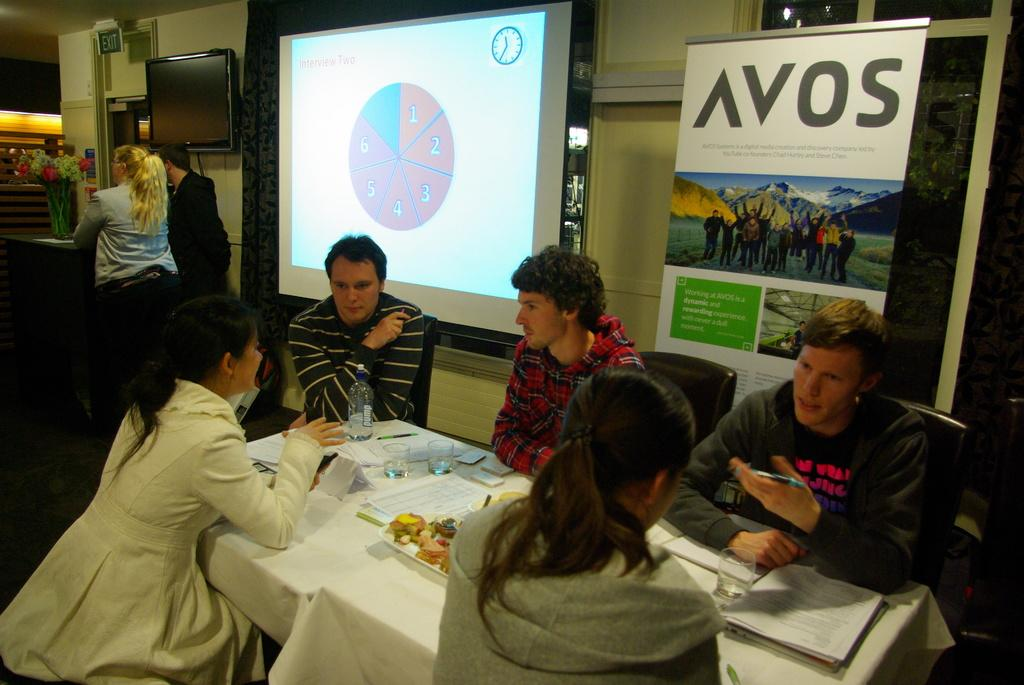What are the people in the image doing? People are sitting on chairs near a table in the image. What objects can be seen on the table? There is a bottle, a paper, a glass, a flower, and a book on the table. Is there any electronic device present in the image? Yes, there is a screen present in the image. What additional item can be found on or near the table? There is a poster on the table or nearby. What type of eggnog is being served in the image? There is no eggnog present in the image. How does the anger of the people in the image affect their body language? There is no indication of anger or any specific body language in the image. 